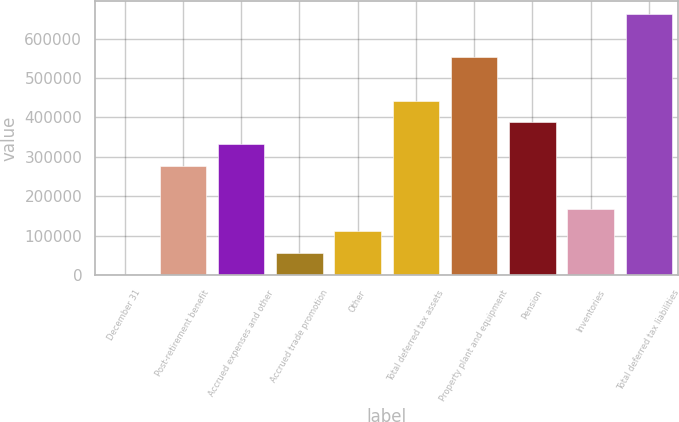Convert chart to OTSL. <chart><loc_0><loc_0><loc_500><loc_500><bar_chart><fcel>December 31<fcel>Post-retirement benefit<fcel>Accrued expenses and other<fcel>Accrued trade promotion<fcel>Other<fcel>Total deferred tax assets<fcel>Property plant and equipment<fcel>Pension<fcel>Inventories<fcel>Total deferred tax liabilities<nl><fcel>2004<fcel>277384<fcel>332460<fcel>57080<fcel>112156<fcel>442612<fcel>552764<fcel>387536<fcel>167232<fcel>662916<nl></chart> 